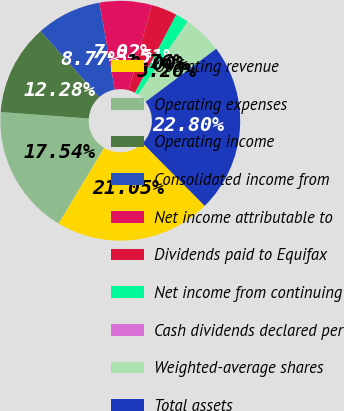Convert chart. <chart><loc_0><loc_0><loc_500><loc_500><pie_chart><fcel>Operating revenue<fcel>Operating expenses<fcel>Operating income<fcel>Consolidated income from<fcel>Net income attributable to<fcel>Dividends paid to Equifax<fcel>Net income from continuing<fcel>Cash dividends declared per<fcel>Weighted-average shares<fcel>Total assets<nl><fcel>21.05%<fcel>17.54%<fcel>12.28%<fcel>8.77%<fcel>7.02%<fcel>3.51%<fcel>1.76%<fcel>0.0%<fcel>5.26%<fcel>22.8%<nl></chart> 